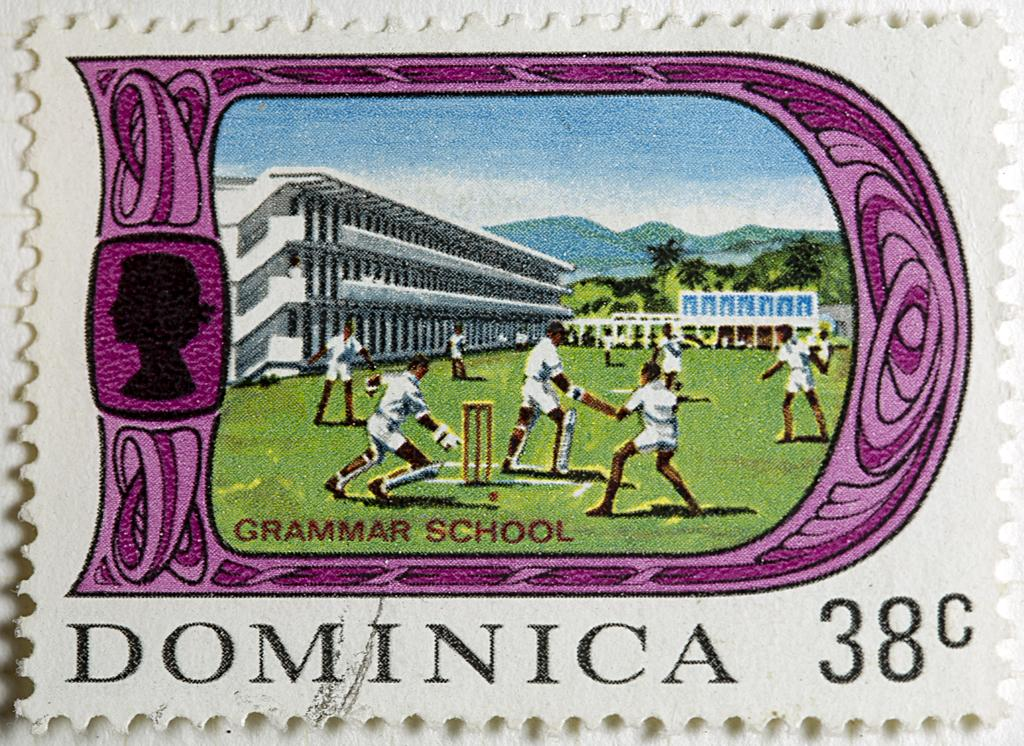Provide a one-sentence caption for the provided image. A grammar school themed postage stamp is worth 38 cents. 